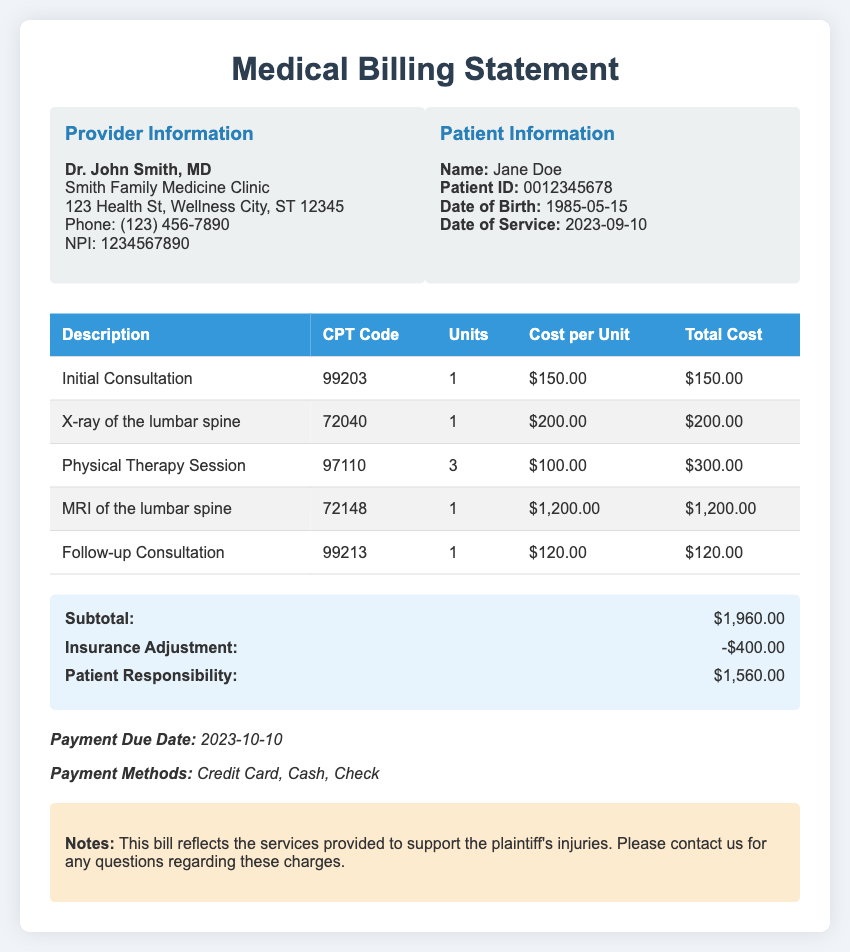what is the patient's name? The patient's name is listed under Patient Information in the document.
Answer: Jane Doe what is the date of service? The date of service is provided in the Patient Information section of the document.
Answer: 2023-09-10 how many units of Physical Therapy Session were billed? The number of units is specified in the table under the Units column for Physical Therapy Session.
Answer: 3 what is the total cost for the MRI of the lumbar spine? The total cost is shown in the Total Cost column for the MRI of the lumbar spine in the billing statement.
Answer: $1,200.00 what is the subtotal amount before adjustments? The subtotal amount is given in the total section, which sums up all the services rendered.
Answer: $1,960.00 what is the amount of the insurance adjustment? The insurance adjustment is noted in the total section as a reduction amount.
Answer: -$400.00 what is the patient responsibility amount? The patient responsibility amount can be found in the total section as the final amount due after adjustments.
Answer: $1,560.00 who is the provider of the services? The provider's information is prominently displayed at the top of the document.
Answer: Dr. John Smith, MD what payment methods are accepted? The document lists the payment methods that can be used by the patient to settle the bill.
Answer: Credit Card, Cash, Check when is the payment due date? The due date for payment is mentioned in the payment info section of the document.
Answer: 2023-10-10 